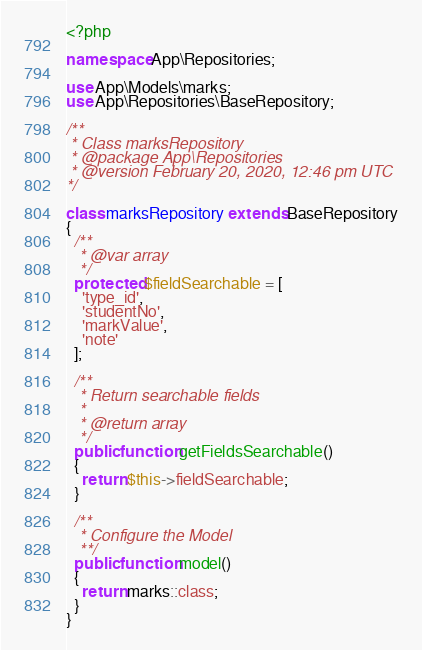<code> <loc_0><loc_0><loc_500><loc_500><_PHP_><?php

namespace App\Repositories;

use App\Models\marks;
use App\Repositories\BaseRepository;

/**
 * Class marksRepository
 * @package App\Repositories
 * @version February 20, 2020, 12:46 pm UTC
*/

class marksRepository extends BaseRepository
{
  /**
   * @var array
   */
  protected $fieldSearchable = [
    'type_id',
    'studentNo',
    'markValue',
    'note'
  ];

  /**
   * Return searchable fields
   *
   * @return array
   */
  public function getFieldsSearchable()
  {
    return $this->fieldSearchable;
  }

  /**
   * Configure the Model
   **/
  public function model()
  {
    return marks::class;
  }
}
</code> 